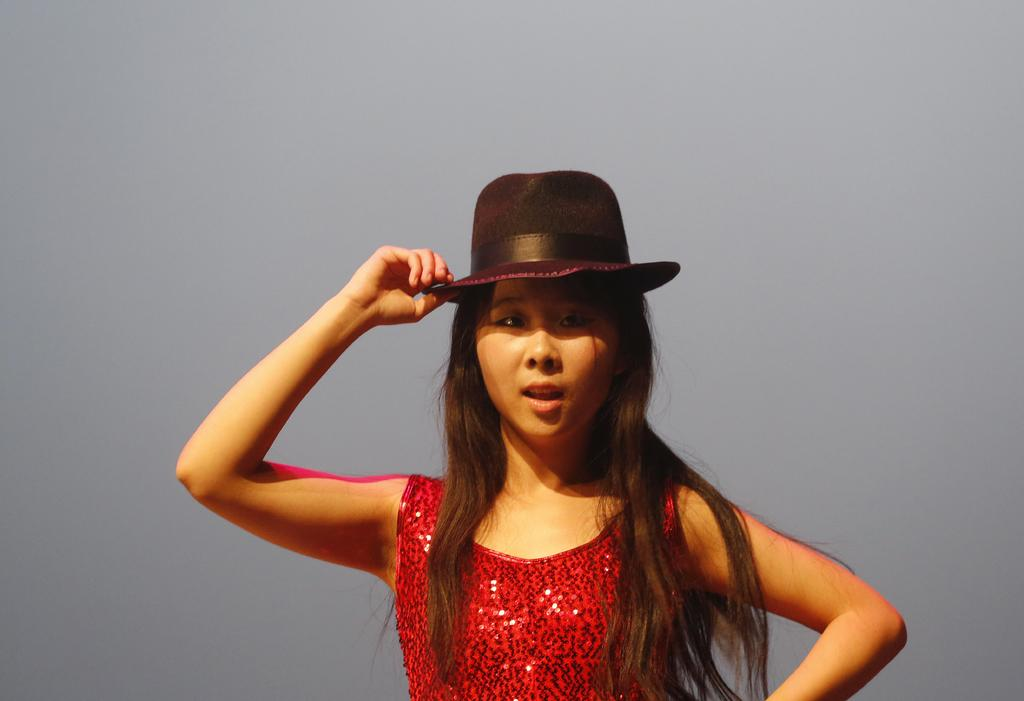Who is present in the image? There is a woman in the image. What is the woman wearing on her head? The woman is wearing a hat. How many books does the woman have in her hands in the image? There is no mention of books in the image, so we cannot determine how many books the woman might have in her hands. 